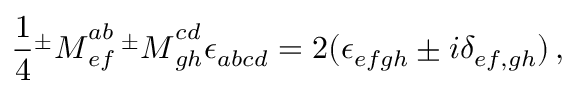<formula> <loc_0><loc_0><loc_500><loc_500>\frac { 1 } { 4 } { ^ { \pm } M } _ { e f } ^ { a b } \, { ^ { \pm } M } _ { g h } ^ { c d } \epsilon _ { a b c d } = 2 ( \epsilon _ { e f g h } \pm i \delta _ { e f , g h } ) \, ,</formula> 